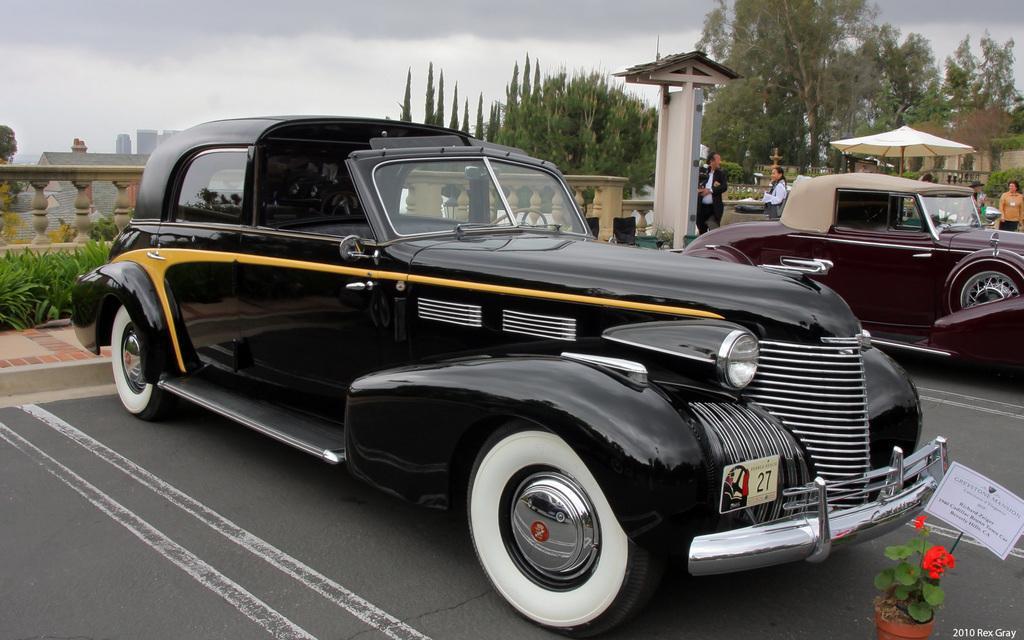How would you summarize this image in a sentence or two? In this image we can see two vehicles, there are some trees, plants, people, fence, buildings, chairs, tent and a potted plant with flowers and a poster, in the background we can see the sky with clouds. 